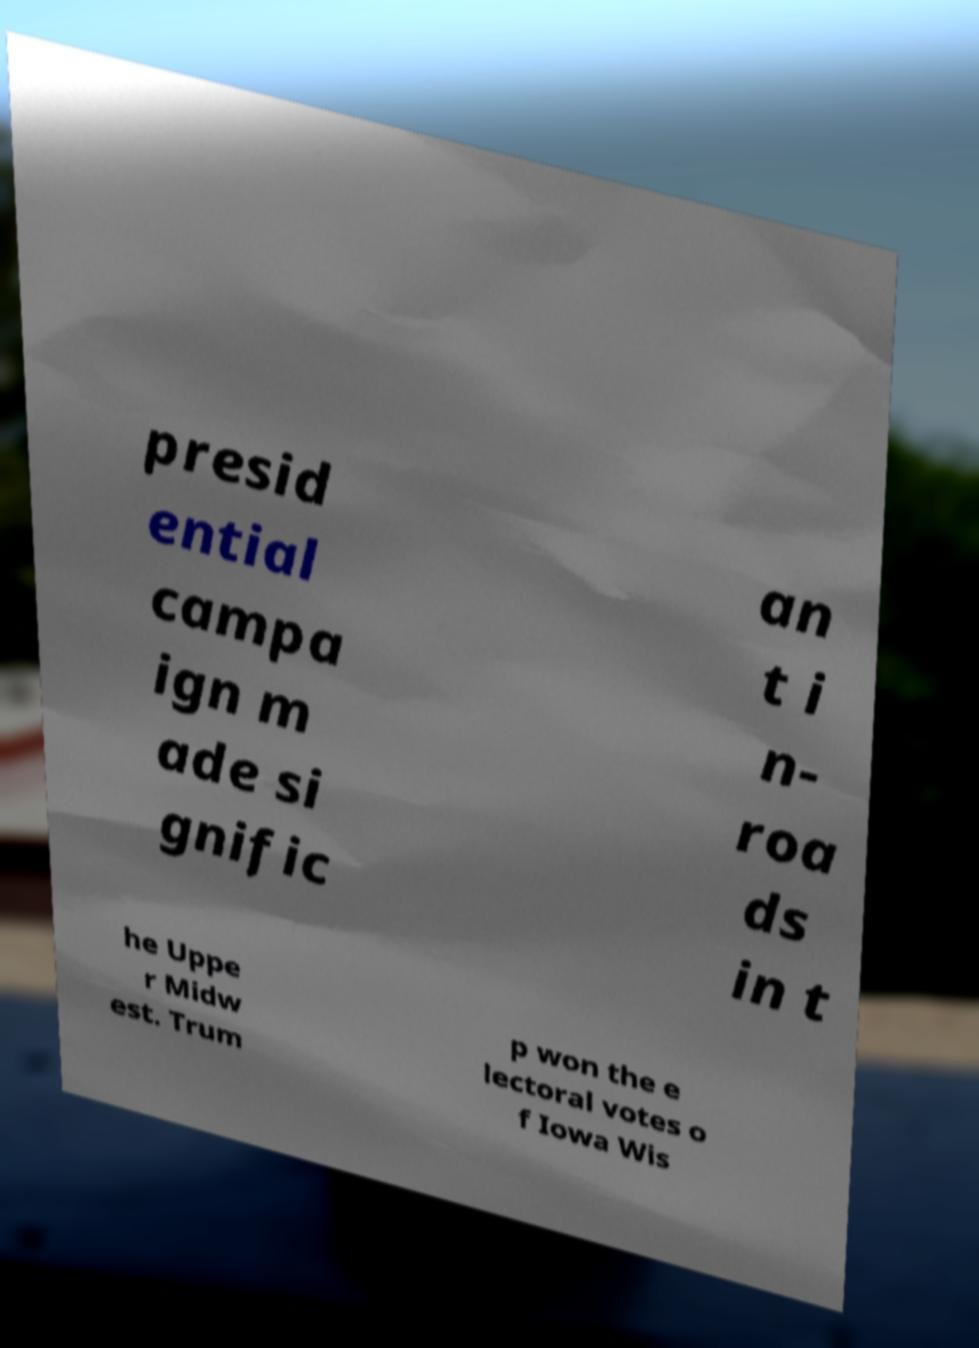Could you assist in decoding the text presented in this image and type it out clearly? presid ential campa ign m ade si gnific an t i n- roa ds in t he Uppe r Midw est. Trum p won the e lectoral votes o f Iowa Wis 